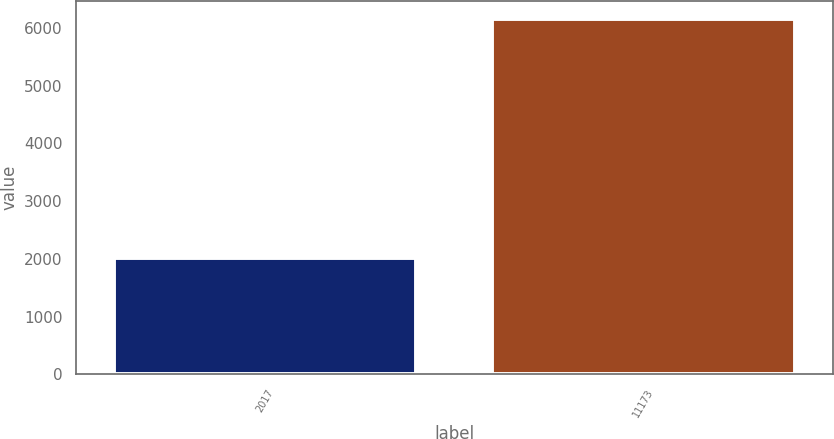Convert chart. <chart><loc_0><loc_0><loc_500><loc_500><bar_chart><fcel>2017<fcel>11173<nl><fcel>2015<fcel>6154<nl></chart> 